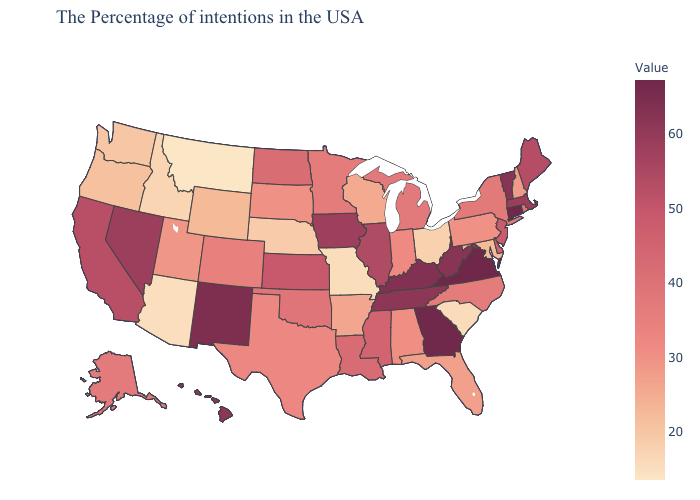Which states have the highest value in the USA?
Write a very short answer. Connecticut, Virginia. Which states hav the highest value in the Northeast?
Short answer required. Connecticut. Among the states that border Mississippi , which have the highest value?
Quick response, please. Tennessee. Does the map have missing data?
Be succinct. No. Which states have the highest value in the USA?
Answer briefly. Connecticut, Virginia. Does Montana have the lowest value in the USA?
Write a very short answer. Yes. 